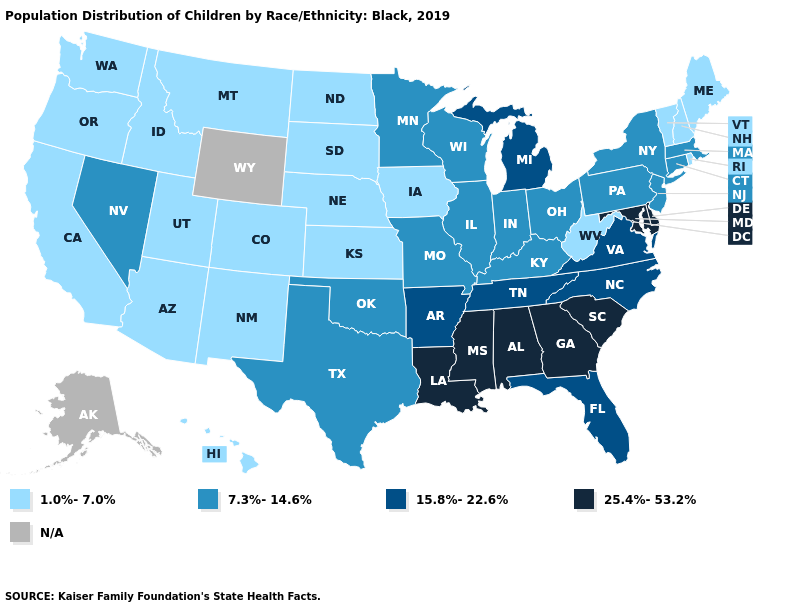Is the legend a continuous bar?
Concise answer only. No. Name the states that have a value in the range 25.4%-53.2%?
Answer briefly. Alabama, Delaware, Georgia, Louisiana, Maryland, Mississippi, South Carolina. Name the states that have a value in the range 15.8%-22.6%?
Concise answer only. Arkansas, Florida, Michigan, North Carolina, Tennessee, Virginia. What is the highest value in states that border Connecticut?
Answer briefly. 7.3%-14.6%. What is the value of Pennsylvania?
Short answer required. 7.3%-14.6%. Does Colorado have the highest value in the West?
Be succinct. No. What is the value of Indiana?
Give a very brief answer. 7.3%-14.6%. What is the value of Indiana?
Be succinct. 7.3%-14.6%. What is the highest value in the Northeast ?
Be succinct. 7.3%-14.6%. Does Nevada have the highest value in the West?
Give a very brief answer. Yes. What is the value of Mississippi?
Keep it brief. 25.4%-53.2%. Which states have the lowest value in the West?
Give a very brief answer. Arizona, California, Colorado, Hawaii, Idaho, Montana, New Mexico, Oregon, Utah, Washington. Name the states that have a value in the range 1.0%-7.0%?
Answer briefly. Arizona, California, Colorado, Hawaii, Idaho, Iowa, Kansas, Maine, Montana, Nebraska, New Hampshire, New Mexico, North Dakota, Oregon, Rhode Island, South Dakota, Utah, Vermont, Washington, West Virginia. Is the legend a continuous bar?
Answer briefly. No. 